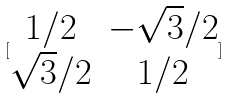<formula> <loc_0><loc_0><loc_500><loc_500>[ \begin{matrix} 1 / 2 & - \sqrt { 3 } / 2 \\ \sqrt { 3 } / 2 & 1 / 2 \end{matrix} ]</formula> 